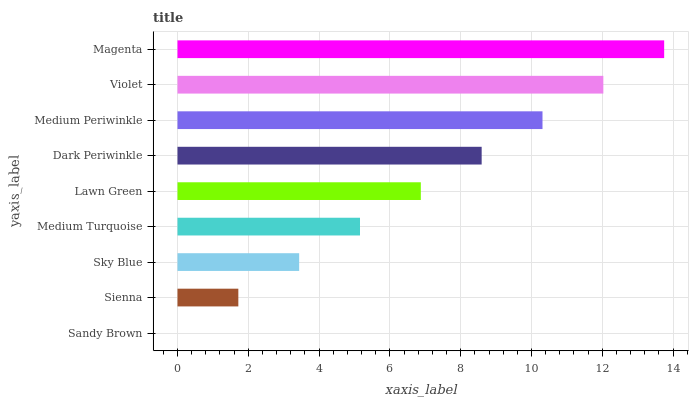Is Sandy Brown the minimum?
Answer yes or no. Yes. Is Magenta the maximum?
Answer yes or no. Yes. Is Sienna the minimum?
Answer yes or no. No. Is Sienna the maximum?
Answer yes or no. No. Is Sienna greater than Sandy Brown?
Answer yes or no. Yes. Is Sandy Brown less than Sienna?
Answer yes or no. Yes. Is Sandy Brown greater than Sienna?
Answer yes or no. No. Is Sienna less than Sandy Brown?
Answer yes or no. No. Is Lawn Green the high median?
Answer yes or no. Yes. Is Lawn Green the low median?
Answer yes or no. Yes. Is Medium Turquoise the high median?
Answer yes or no. No. Is Magenta the low median?
Answer yes or no. No. 